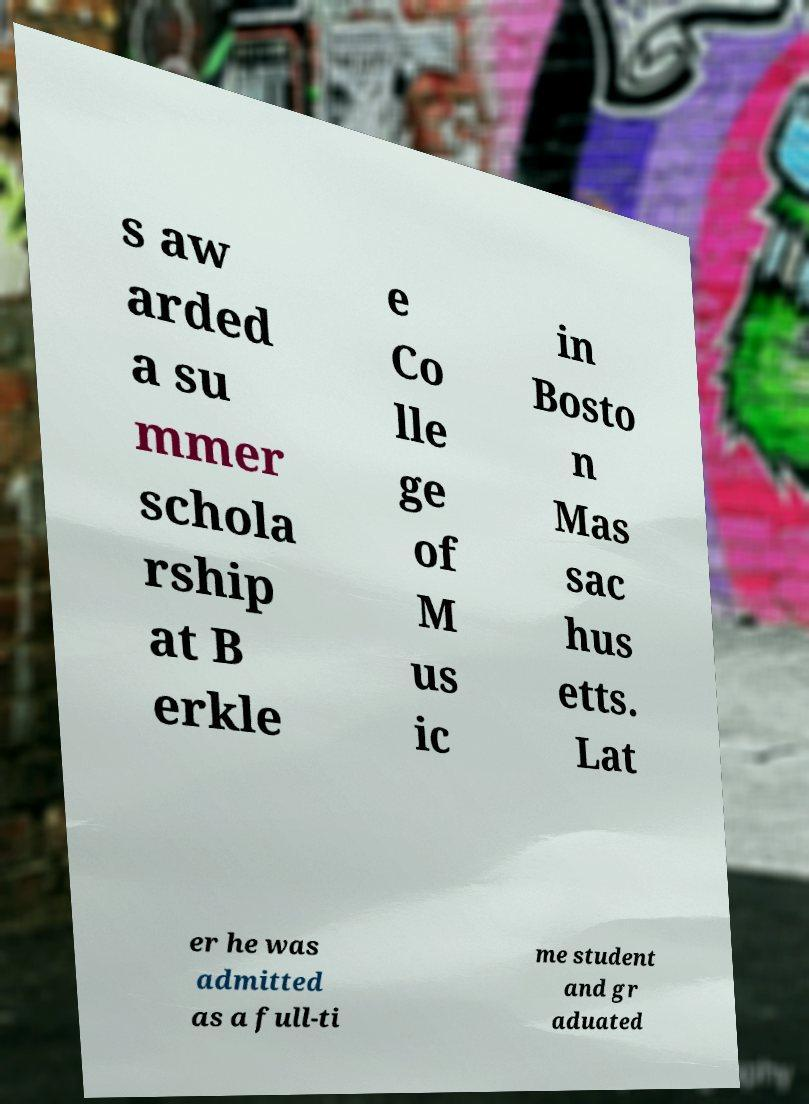I need the written content from this picture converted into text. Can you do that? s aw arded a su mmer schola rship at B erkle e Co lle ge of M us ic in Bosto n Mas sac hus etts. Lat er he was admitted as a full-ti me student and gr aduated 